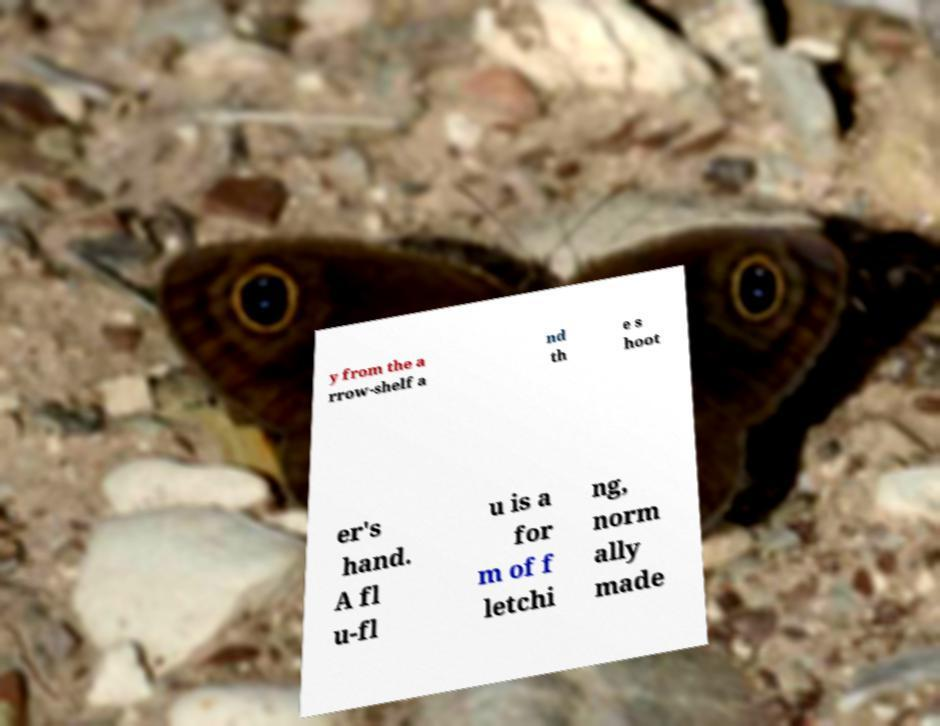Could you extract and type out the text from this image? y from the a rrow-shelf a nd th e s hoot er's hand. A fl u-fl u is a for m of f letchi ng, norm ally made 